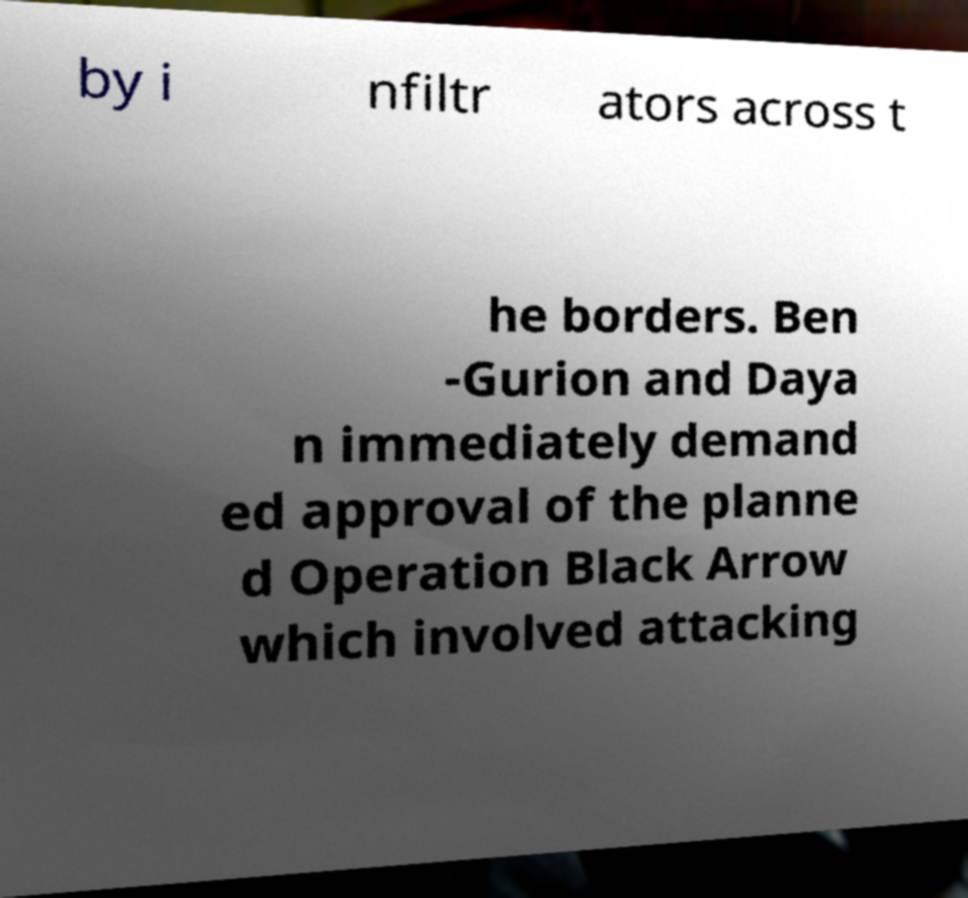Could you assist in decoding the text presented in this image and type it out clearly? by i nfiltr ators across t he borders. Ben -Gurion and Daya n immediately demand ed approval of the planne d Operation Black Arrow which involved attacking 